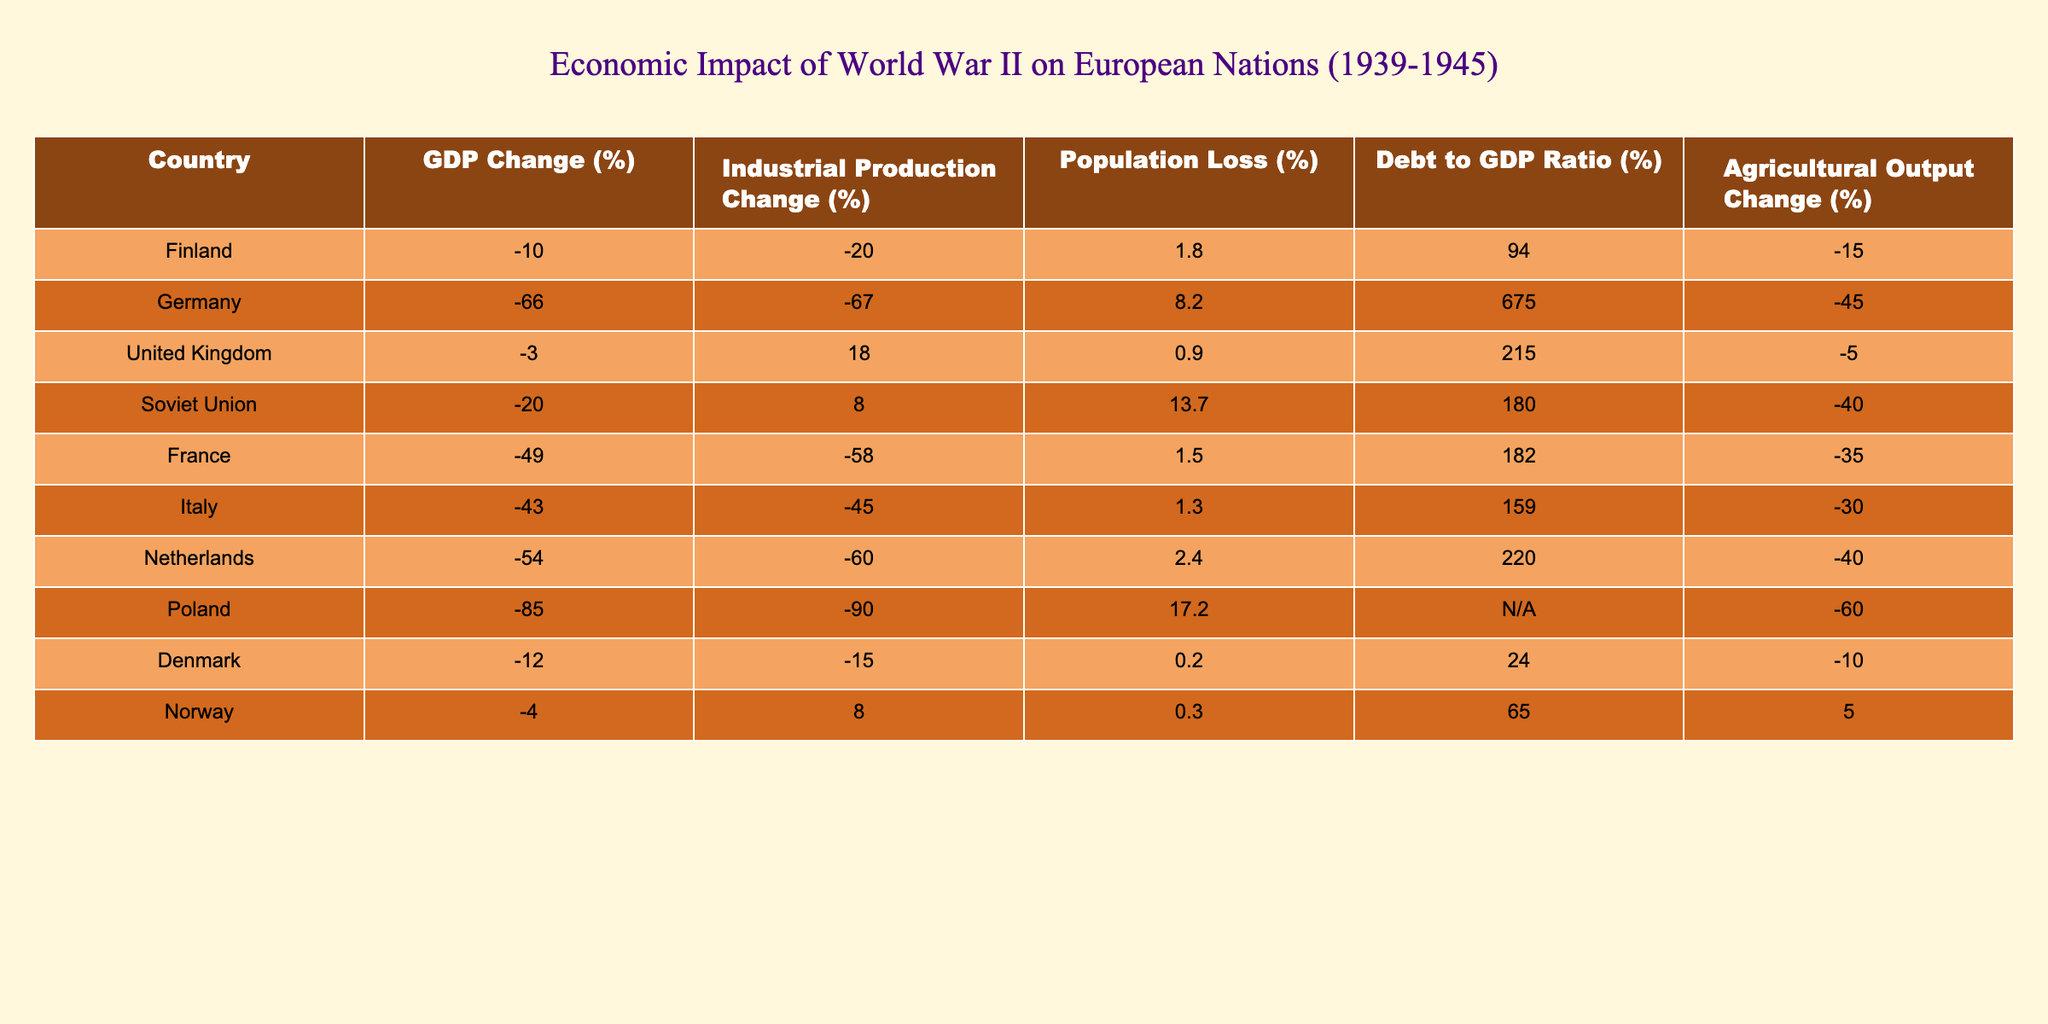What is the GDP change percentage for Germany? Referring to the table, Germany has a GDP change percentage of -66%.
Answer: -66% Which country experienced the highest population loss percentage? By examining the population loss percentages, Poland has the highest value at 17.2%.
Answer: 17.2% What is the average agricultural output change percentage for the countries listed? Summing the agricultural output change percentages: (-15 + -45 + -5 + -40 + -35 + -30 + -60 + 5) = -225. There are 8 countries, so the average is -225/8 = -28.125%.
Answer: -28.1% Did the United Kingdom experience a debt to GDP ratio above 200%? The debt to GDP ratio for the United Kingdom is 215%, which is above 200%, so the answer is yes.
Answer: Yes Which country had the least industrial production change? Checking the industrial production changes, Germany suffered the most significant decrease at -67%.
Answer: -67% What is the total debt to GDP ratio of Finland and Norway combined? Adding the debt to GDP ratios of Finland (94%) and Norway (65%): 94 + 65 = 159%.
Answer: 159% Was the agricultural output percentage change for Italy less than that of Finland? Italy shows -30%, while Finland shows -15%. Since -30% is less than -15%, the answer is true.
Answer: True Which country had a lower GDP change, France or the Netherlands? France had a GDP change of -49%, while the Netherlands had -54%. Since -54% is lower, the Netherlands experienced a more significant decline than France.
Answer: Netherlands What is the difference in population loss percentage between Poland and the Soviet Union? Poland's population loss is 17.2% and the Soviet Union's is 13.7%. The difference is 17.2% - 13.7% = 3.5%.
Answer: 3.5% Is it true that all countries listed had a negative GDP change? All listed countries except for Norway show a negative GDP change. Therefore, it is not true that all had negative changes.
Answer: No 